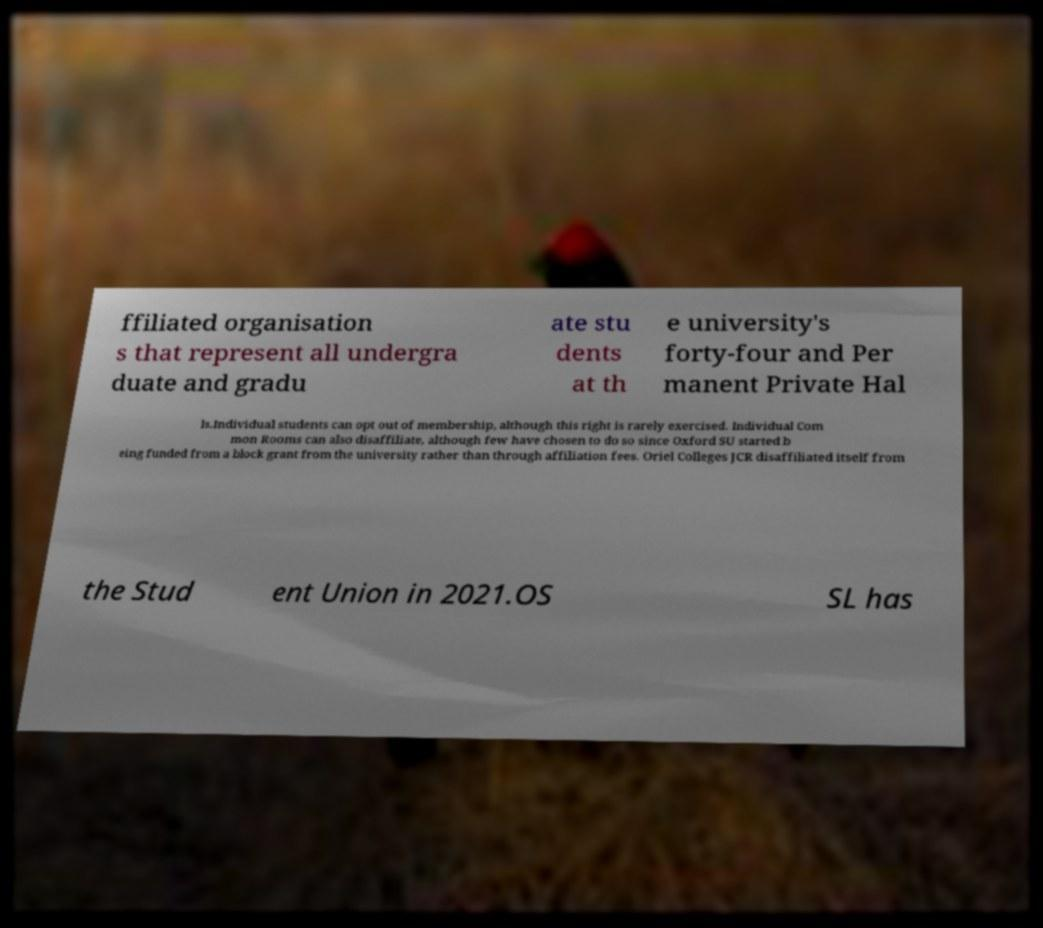Please read and relay the text visible in this image. What does it say? ffiliated organisation s that represent all undergra duate and gradu ate stu dents at th e university's forty-four and Per manent Private Hal ls.Individual students can opt out of membership, although this right is rarely exercised. Individual Com mon Rooms can also disaffiliate, although few have chosen to do so since Oxford SU started b eing funded from a block grant from the university rather than through affiliation fees. Oriel Colleges JCR disaffiliated itself from the Stud ent Union in 2021.OS SL has 